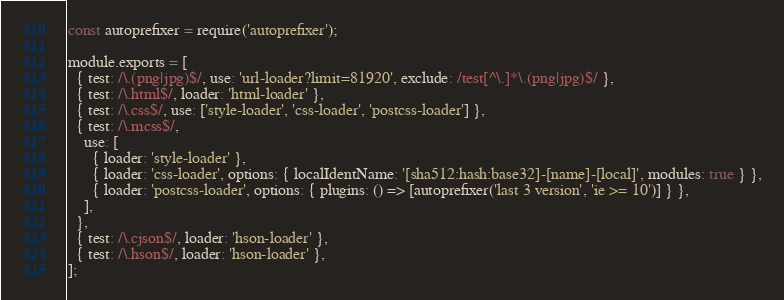Convert code to text. <code><loc_0><loc_0><loc_500><loc_500><_JavaScript_>const autoprefixer = require('autoprefixer');

module.exports = [
  { test: /\.(png|jpg)$/, use: 'url-loader?limit=81920', exclude: /test[^\.]*\.(png|jpg)$/ },
  { test: /\.html$/, loader: 'html-loader' },
  { test: /\.css$/, use: ['style-loader', 'css-loader', 'postcss-loader'] },
  { test: /\.mcss$/,
    use: [
      { loader: 'style-loader' },
      { loader: 'css-loader', options: { localIdentName: '[sha512:hash:base32]-[name]-[local]', modules: true } },
      { loader: 'postcss-loader', options: { plugins: () => [autoprefixer('last 3 version', 'ie >= 10')] } },
    ],
  },
  { test: /\.cjson$/, loader: 'hson-loader' },
  { test: /\.hson$/, loader: 'hson-loader' },
];
</code> 